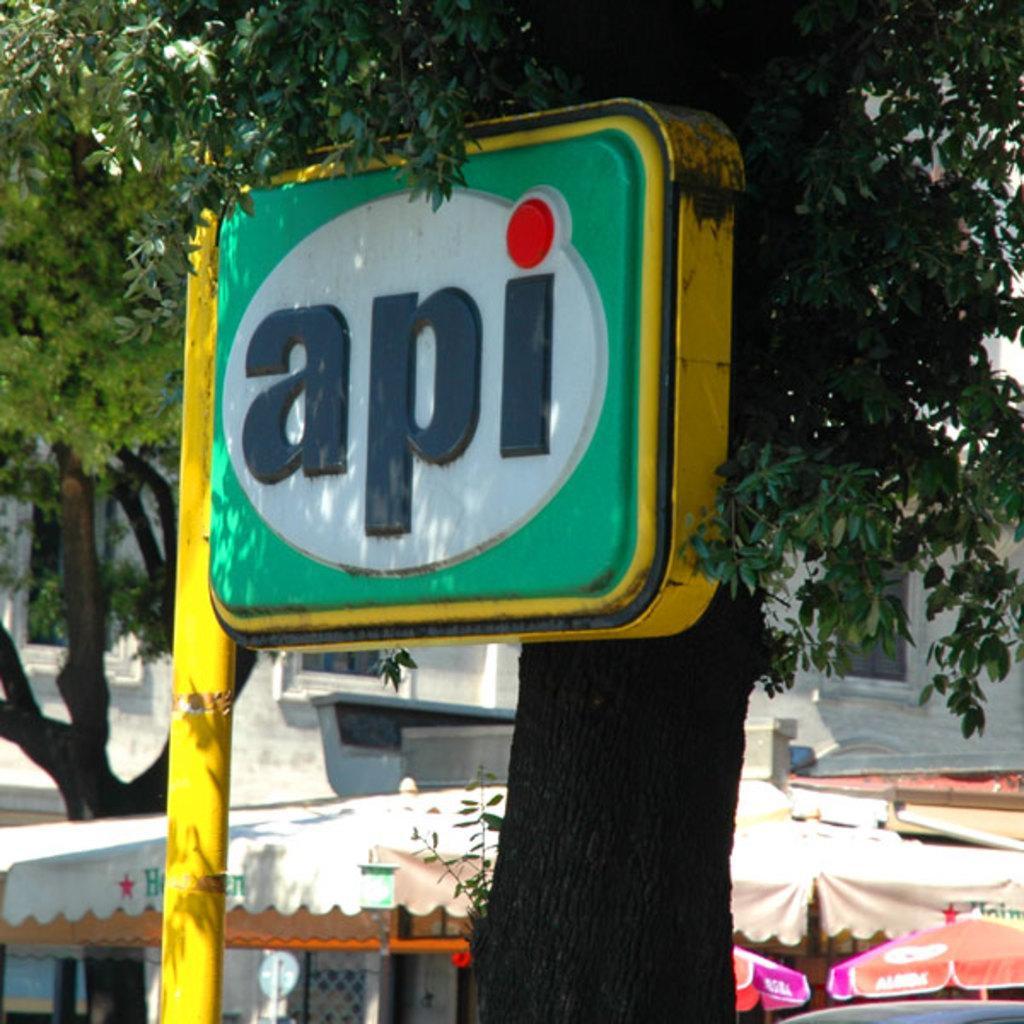Describe this image in one or two sentences. In this image I can see the colorful board to the side of the tree. In the back I can see the tents and the building. 